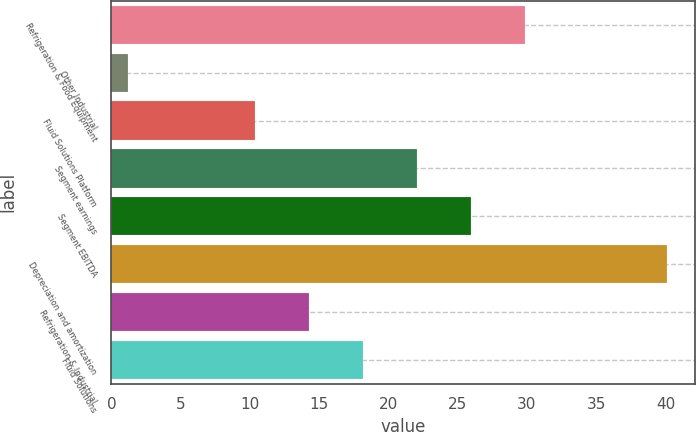Convert chart to OTSL. <chart><loc_0><loc_0><loc_500><loc_500><bar_chart><fcel>Refrigeration & Food Equipment<fcel>Other Industrial<fcel>Fluid Solutions Platform<fcel>Segment earnings<fcel>Segment EBITDA<fcel>Depreciation and amortization<fcel>Refrigeration & Industrial<fcel>Fluid Solutions<nl><fcel>29.85<fcel>1.2<fcel>10.4<fcel>22.07<fcel>25.96<fcel>40.1<fcel>14.29<fcel>18.18<nl></chart> 